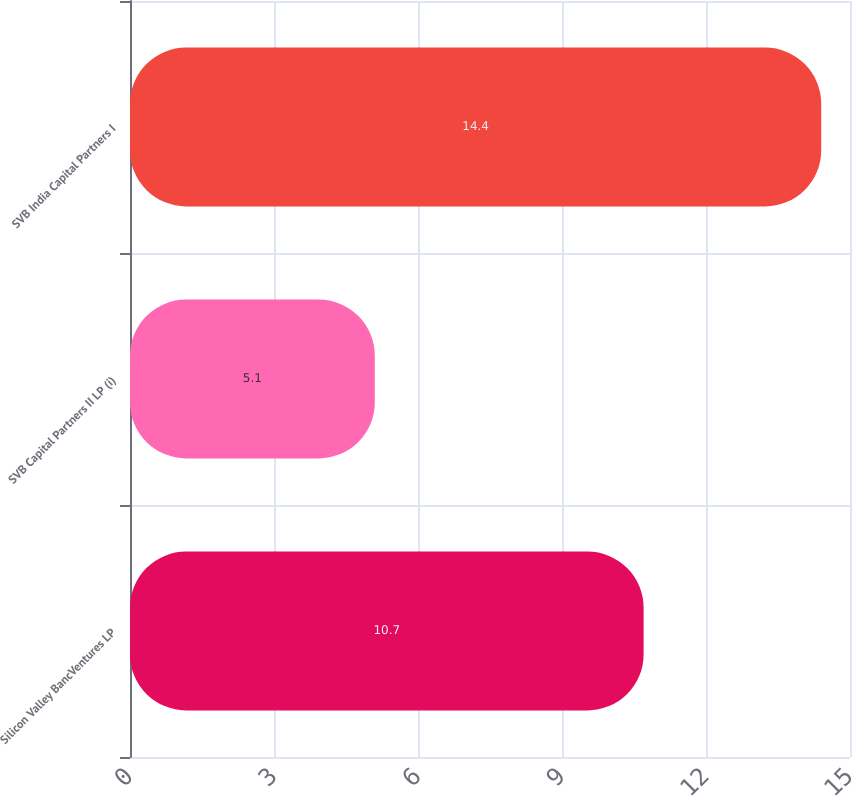<chart> <loc_0><loc_0><loc_500><loc_500><bar_chart><fcel>Silicon Valley BancVentures LP<fcel>SVB Capital Partners II LP (i)<fcel>SVB India Capital Partners I<nl><fcel>10.7<fcel>5.1<fcel>14.4<nl></chart> 